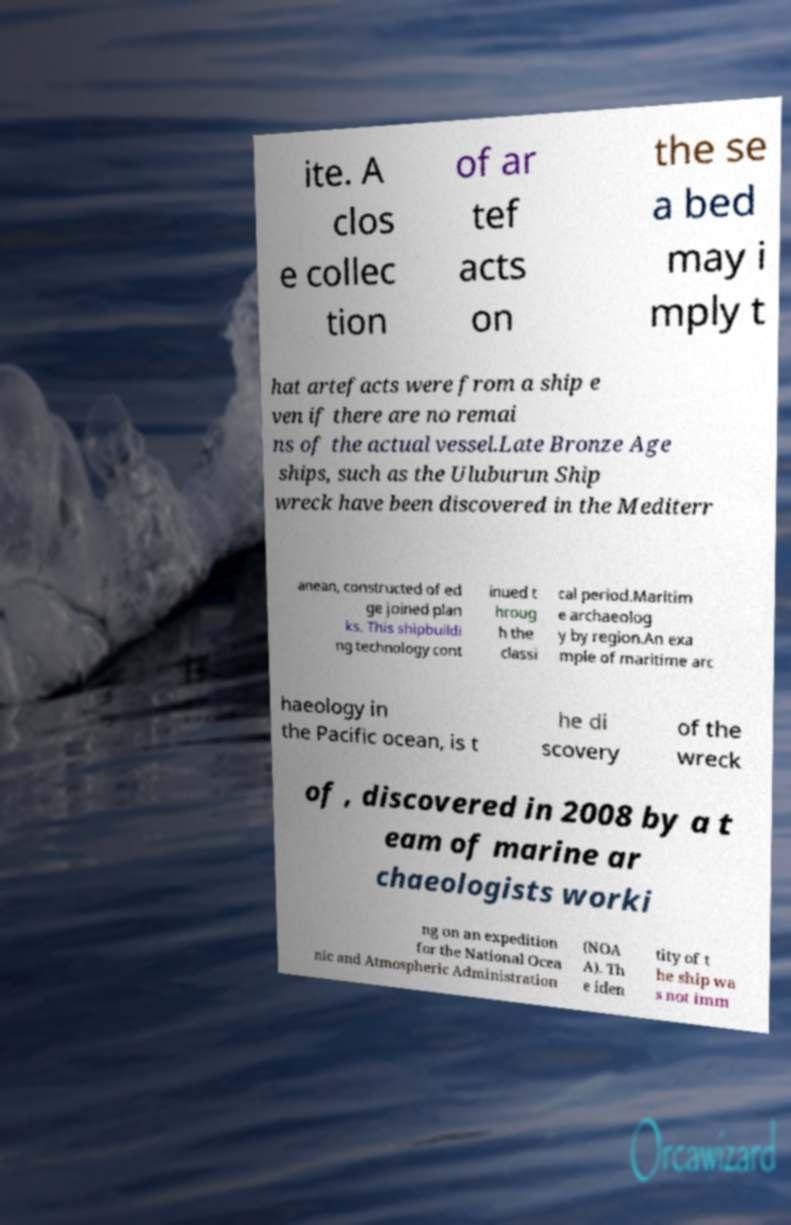Can you accurately transcribe the text from the provided image for me? ite. A clos e collec tion of ar tef acts on the se a bed may i mply t hat artefacts were from a ship e ven if there are no remai ns of the actual vessel.Late Bronze Age ships, such as the Uluburun Ship wreck have been discovered in the Mediterr anean, constructed of ed ge joined plan ks. This shipbuildi ng technology cont inued t hroug h the classi cal period.Maritim e archaeolog y by region.An exa mple of maritime arc haeology in the Pacific ocean, is t he di scovery of the wreck of , discovered in 2008 by a t eam of marine ar chaeologists worki ng on an expedition for the National Ocea nic and Atmospheric Administration (NOA A). Th e iden tity of t he ship wa s not imm 